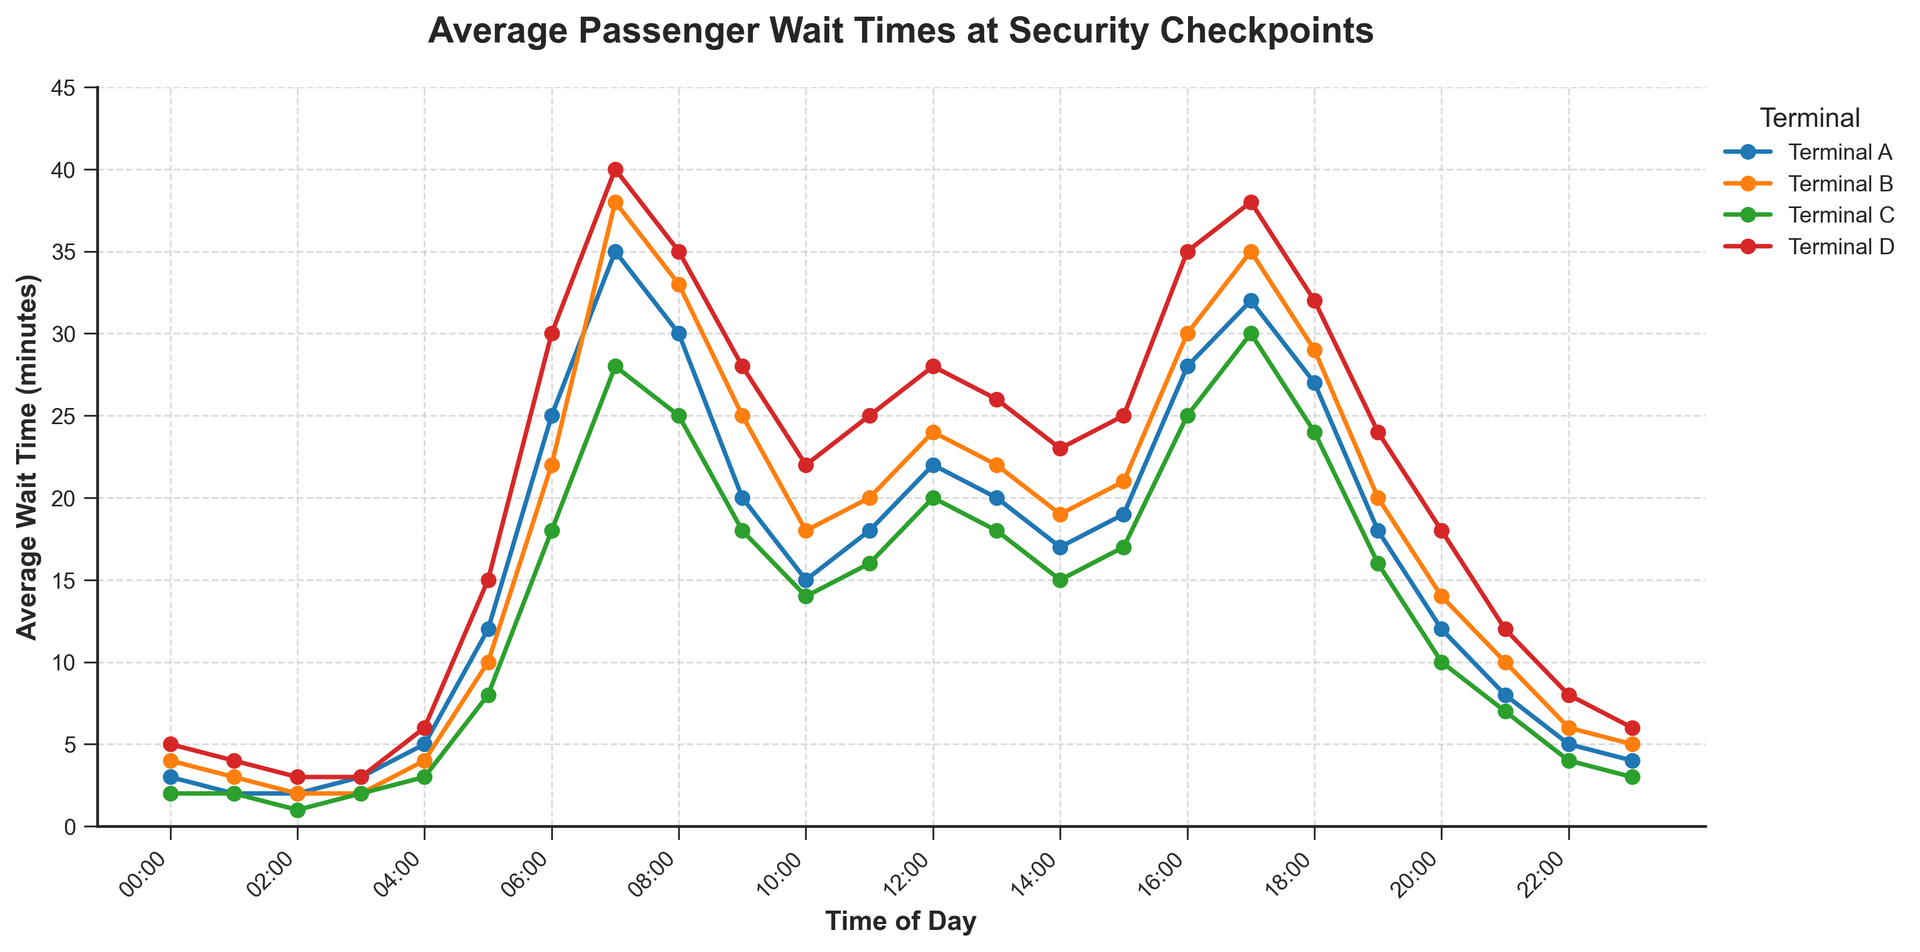What time of day does Terminal D experience the highest average wait time? Look at the line for Terminal D on the chart. The peak point occurs between 17:00 and 18:00 hours.
Answer: Between 17:00 and 18:00 During which hours does Terminal C have the lowest average wait times? Refer to the Terminal C line in the figure. The lowest points where the averages are minimum occur around 02:00 and 03:00 hours.
Answer: Between 02:00 and 03:00 Which terminal has the highest average wait time at 08:00? Compare the y-values of all terminals at 08:00 hours. Terminal D has the highest value at this hour.
Answer: Terminal D What is the range of wait times for Terminal A throughout the day? Identify the minimum and maximum values in Terminal A's data. The minimum is 2 (01:00 and 02:00) and the maximum is 35 (07:00). The range is calculated as maximum minus minimum: 35 - 2 = 33.
Answer: 33 minutes How does the average wait time at 12:00 compare between Terminal B and Terminal C? Look at the y-values of Terminal B and Terminal C at 12:00 hours. For Terminal B, it is 24, and for Terminal C, it is 20. Terminal B's wait time is 4 minutes greater than Terminal C's.
Answer: Terminal B is 4 minutes higher At what hour do all terminals experience a significant increase in wait times? Observe the pattern before and after each hourly mark across all terminals. Notice the sharp increase starting from 06:00 to 07:00 across all terminals.
Answer: 06:00 to 07:00 What is the combined average wait time for Terminal A and Terminal B at 09:00? Add the average wait times of Terminal A and Terminal B at 09:00 hours: Terminal A (20) + Terminal B (25). Combined average = 20 + 25 = 45 minutes.
Answer: 45 minutes Between 16:00 and 17:00, how many terminals have wait times of 25 minutes or more? Check each line within the time range of 16:00 to 17:00. Terminals A, B, and D have wait times of 25 minutes or more.
Answer: 3 terminals What is the trend of wait times for Terminal B between 20:00 and 23:00? Follow the line for Terminal B from 20:00 to 23:00. It shows a decreasing trend from 14 (20:00) to 10 (21:00) to 6 (22:00) and finally 5 (23:00).
Answer: Decreasing 